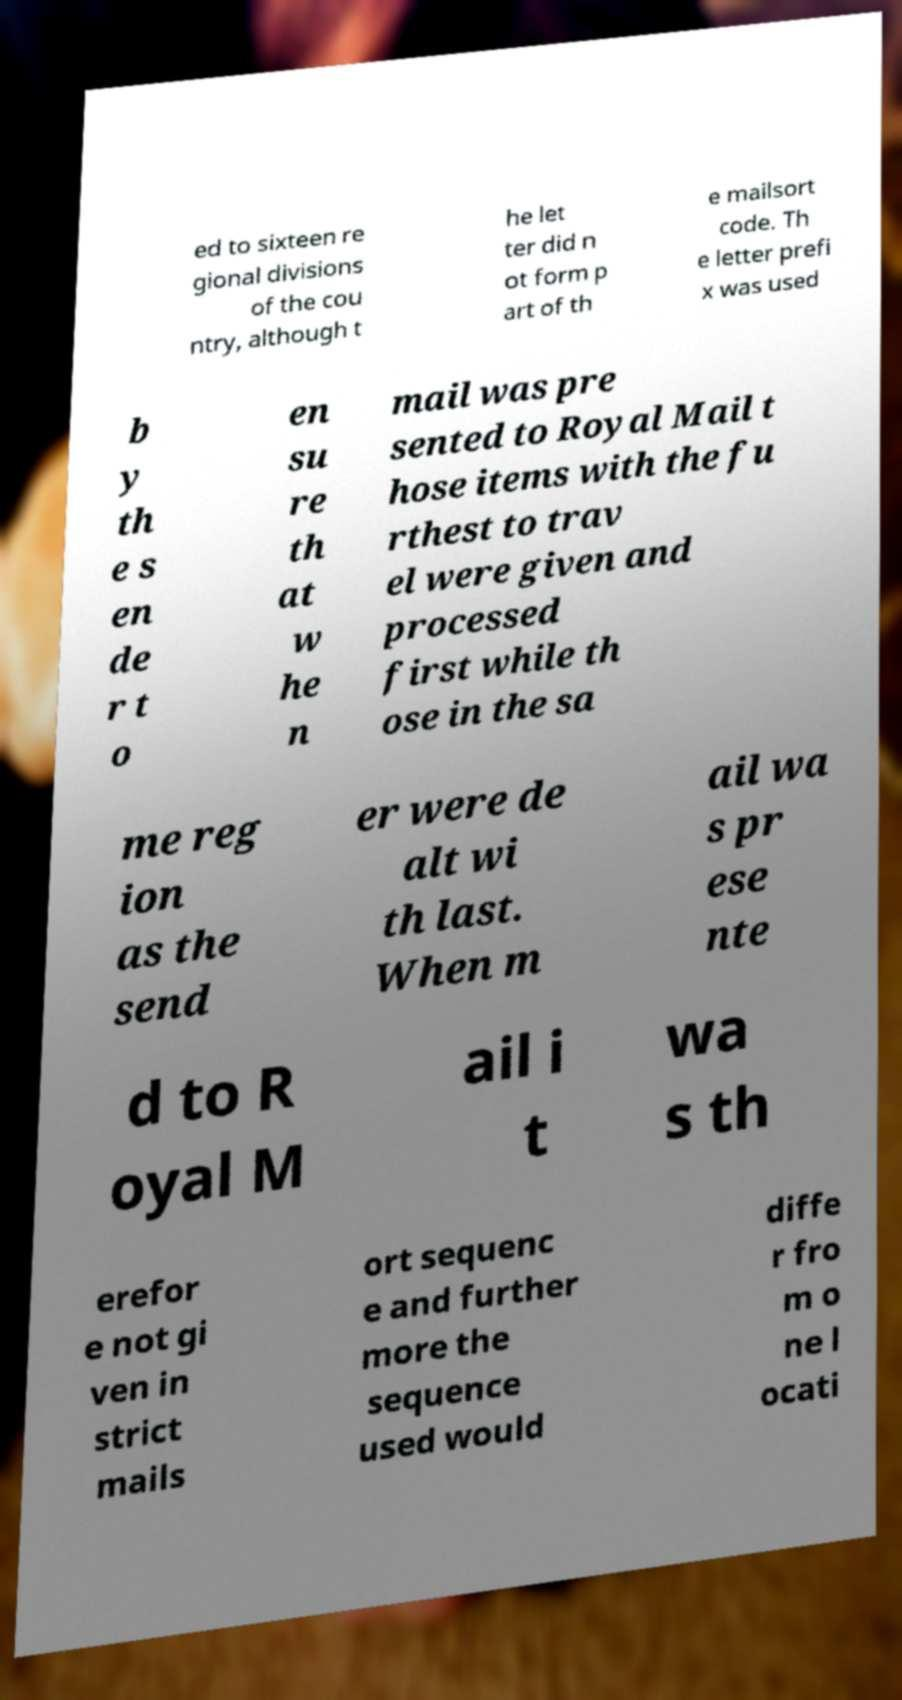Please read and relay the text visible in this image. What does it say? ed to sixteen re gional divisions of the cou ntry, although t he let ter did n ot form p art of th e mailsort code. Th e letter prefi x was used b y th e s en de r t o en su re th at w he n mail was pre sented to Royal Mail t hose items with the fu rthest to trav el were given and processed first while th ose in the sa me reg ion as the send er were de alt wi th last. When m ail wa s pr ese nte d to R oyal M ail i t wa s th erefor e not gi ven in strict mails ort sequenc e and further more the sequence used would diffe r fro m o ne l ocati 